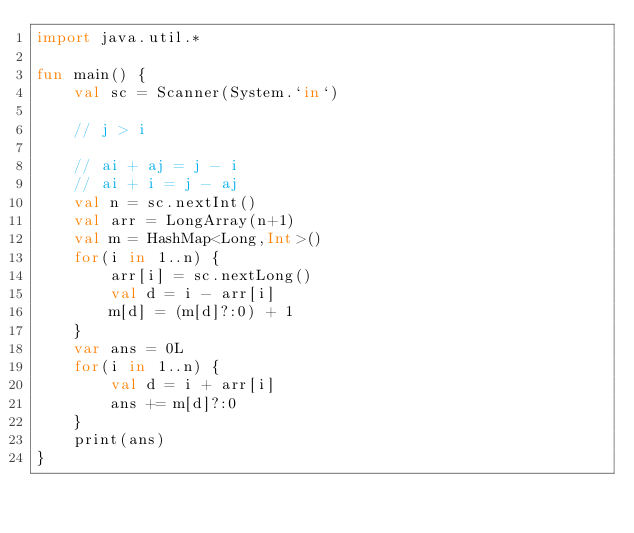<code> <loc_0><loc_0><loc_500><loc_500><_Kotlin_>import java.util.*

fun main() {
    val sc = Scanner(System.`in`)

    // j > i

    // ai + aj = j - i
    // ai + i = j - aj
    val n = sc.nextInt()
    val arr = LongArray(n+1)
    val m = HashMap<Long,Int>()
    for(i in 1..n) {
        arr[i] = sc.nextLong()
        val d = i - arr[i]
        m[d] = (m[d]?:0) + 1
    }
    var ans = 0L
    for(i in 1..n) {
        val d = i + arr[i]
        ans += m[d]?:0
    }
    print(ans)
}</code> 